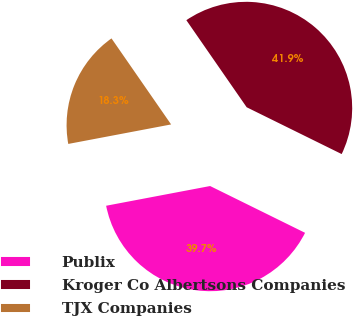Convert chart to OTSL. <chart><loc_0><loc_0><loc_500><loc_500><pie_chart><fcel>Publix<fcel>Kroger Co Albertsons Companies<fcel>TJX Companies<nl><fcel>39.73%<fcel>41.93%<fcel>18.34%<nl></chart> 